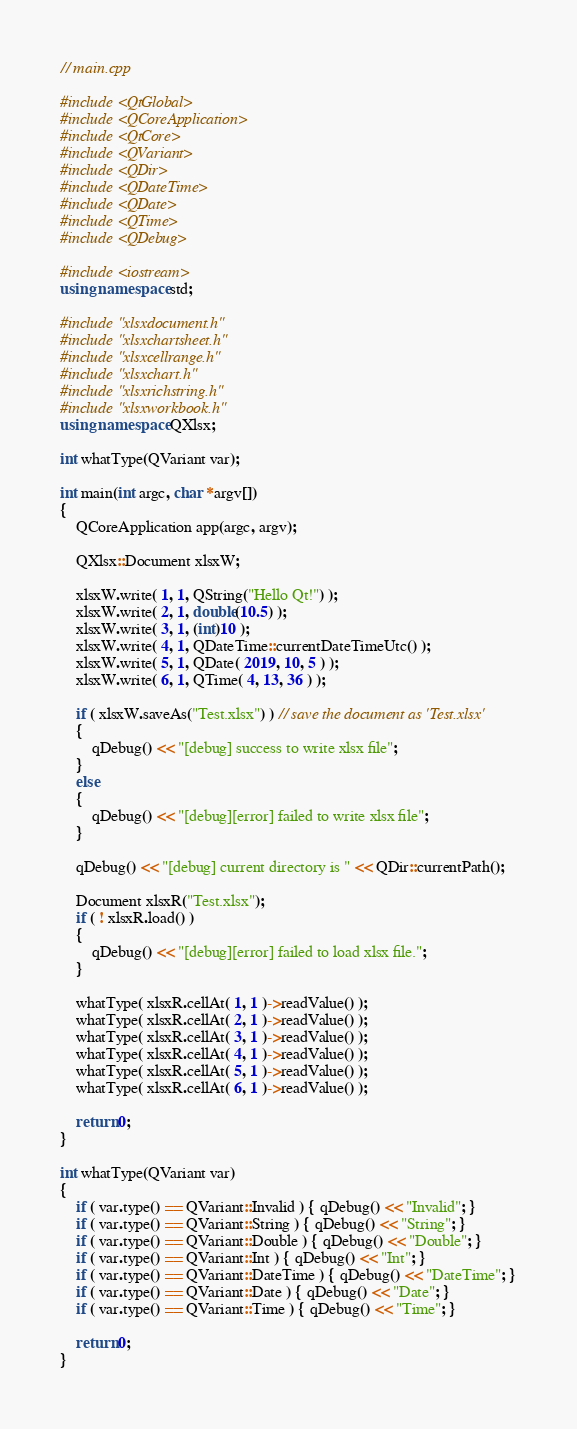<code> <loc_0><loc_0><loc_500><loc_500><_C++_>// main.cpp

#include <QtGlobal>
#include <QCoreApplication>
#include <QtCore>
#include <QVariant>
#include <QDir>
#include <QDateTime>
#include <QDate>
#include <QTime>
#include <QDebug>

#include <iostream>
using namespace std;

#include "xlsxdocument.h"
#include "xlsxchartsheet.h"
#include "xlsxcellrange.h"
#include "xlsxchart.h"
#include "xlsxrichstring.h"
#include "xlsxworkbook.h"
using namespace QXlsx;

int whatType(QVariant var);

int main(int argc, char *argv[])
{
    QCoreApplication app(argc, argv);

    QXlsx::Document xlsxW;

    xlsxW.write( 1, 1, QString("Hello Qt!") );
    xlsxW.write( 2, 1, double(10.5) );
    xlsxW.write( 3, 1, (int)10 );
    xlsxW.write( 4, 1, QDateTime::currentDateTimeUtc() );
    xlsxW.write( 5, 1, QDate( 2019, 10, 5 ) );
    xlsxW.write( 6, 1, QTime( 4, 13, 36 ) );

    if ( xlsxW.saveAs("Test.xlsx") ) // save the document as 'Test.xlsx'
    {
        qDebug() << "[debug] success to write xlsx file";
    }
    else
    {
        qDebug() << "[debug][error] failed to write xlsx file";
    }

    qDebug() << "[debug] current directory is " << QDir::currentPath();

    Document xlsxR("Test.xlsx"); 
    if ( ! xlsxR.load() )
    {
        qDebug() << "[debug][error] failed to load xlsx file.";
    }

    whatType( xlsxR.cellAt( 1, 1 )->readValue() );
    whatType( xlsxR.cellAt( 2, 1 )->readValue() );
    whatType( xlsxR.cellAt( 3, 1 )->readValue() );
    whatType( xlsxR.cellAt( 4, 1 )->readValue() );
    whatType( xlsxR.cellAt( 5, 1 )->readValue() );
    whatType( xlsxR.cellAt( 6, 1 )->readValue() );

    return 0;
}

int whatType(QVariant var)
{
    if ( var.type() == QVariant::Invalid ) { qDebug() << "Invalid"; }
    if ( var.type() == QVariant::String ) { qDebug() << "String"; }
    if ( var.type() == QVariant::Double ) { qDebug() << "Double"; }
    if ( var.type() == QVariant::Int ) { qDebug() << "Int"; }
    if ( var.type() == QVariant::DateTime ) { qDebug() << "DateTime"; }
    if ( var.type() == QVariant::Date ) { qDebug() << "Date"; }
    if ( var.type() == QVariant::Time ) { qDebug() << "Time"; }

    return 0;
}
</code> 